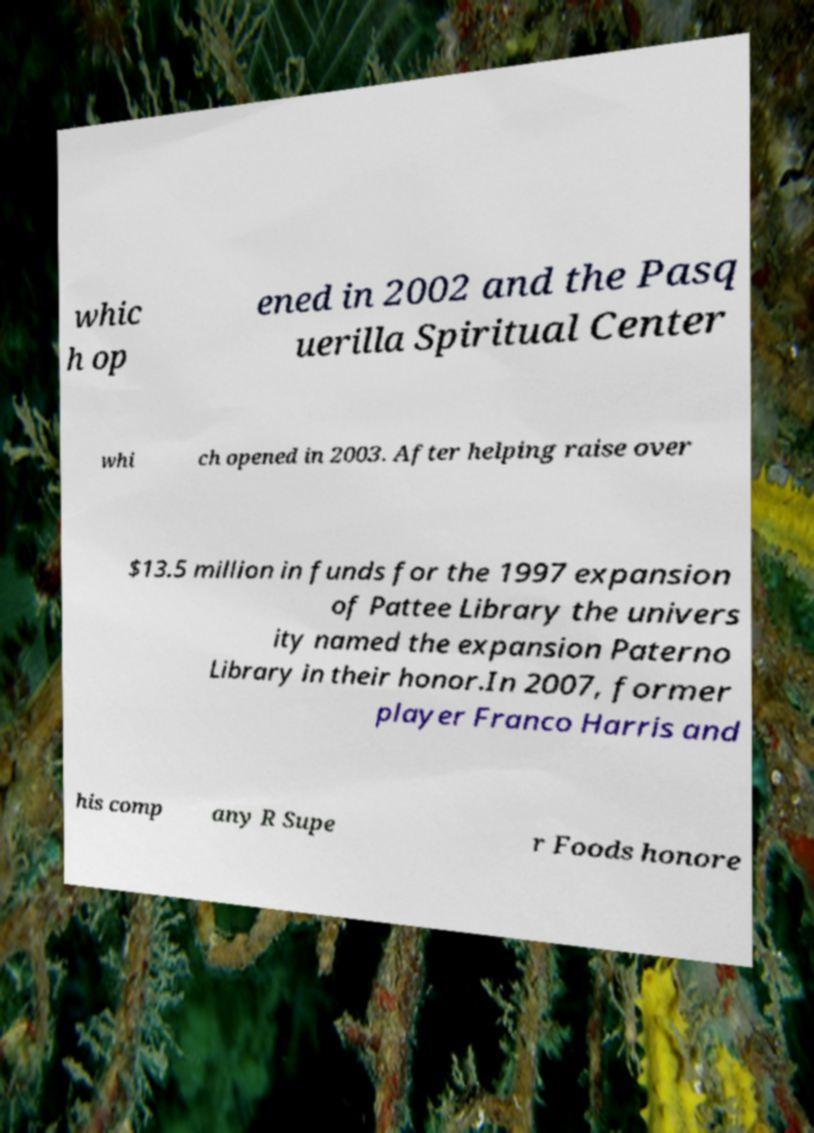Could you assist in decoding the text presented in this image and type it out clearly? whic h op ened in 2002 and the Pasq uerilla Spiritual Center whi ch opened in 2003. After helping raise over $13.5 million in funds for the 1997 expansion of Pattee Library the univers ity named the expansion Paterno Library in their honor.In 2007, former player Franco Harris and his comp any R Supe r Foods honore 